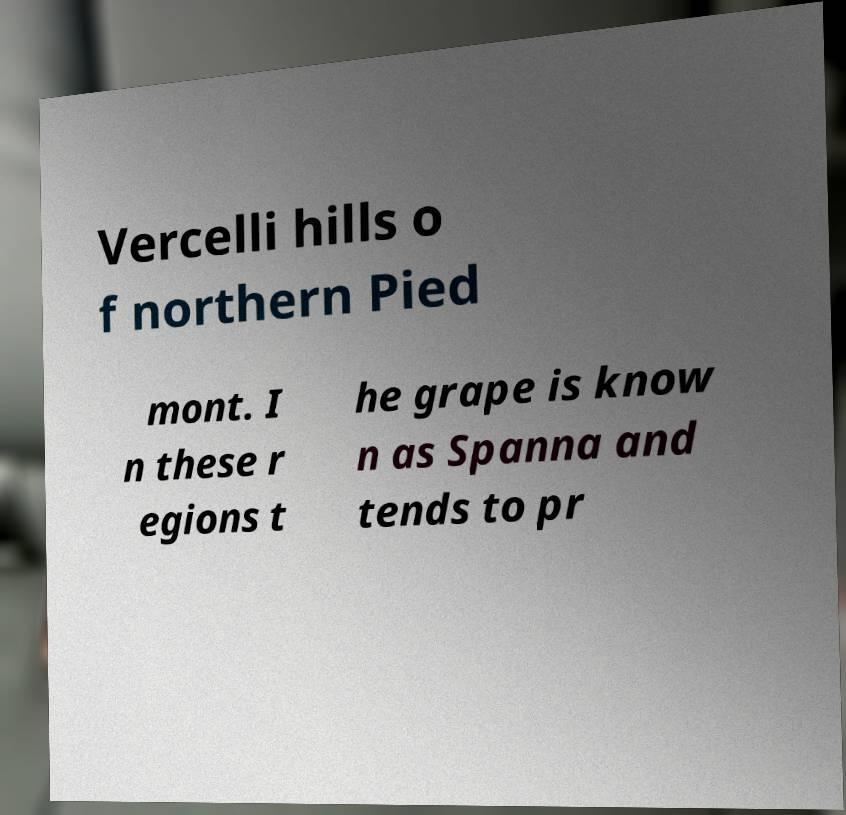Please identify and transcribe the text found in this image. Vercelli hills o f northern Pied mont. I n these r egions t he grape is know n as Spanna and tends to pr 